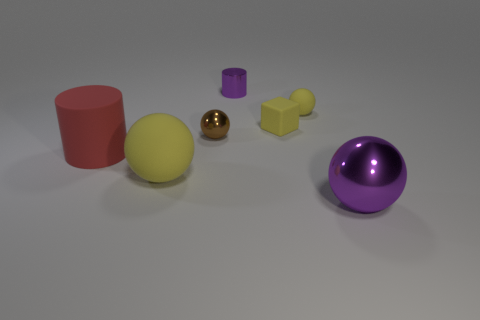Subtract all brown balls. How many balls are left? 3 Subtract all tiny matte balls. How many balls are left? 3 Subtract all red balls. Subtract all gray cylinders. How many balls are left? 4 Add 1 big blue cylinders. How many objects exist? 8 Subtract all balls. How many objects are left? 3 Add 3 large cylinders. How many large cylinders exist? 4 Subtract 0 green balls. How many objects are left? 7 Subtract all small brown objects. Subtract all tiny brown objects. How many objects are left? 5 Add 7 tiny cylinders. How many tiny cylinders are left? 8 